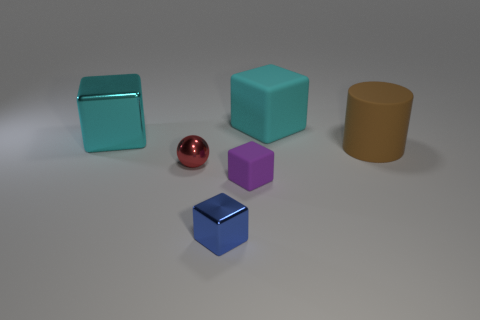What material is the other block that is the same color as the big rubber cube?
Ensure brevity in your answer.  Metal. Do the large metallic block and the big rubber block have the same color?
Offer a terse response. Yes. What number of things are both in front of the big cyan metallic thing and on the right side of the red object?
Offer a very short reply. 3. What number of purple matte things have the same shape as the cyan shiny object?
Your answer should be very brief. 1. What is the color of the matte object on the right side of the large block that is right of the blue thing?
Ensure brevity in your answer.  Brown. Is the shape of the large metallic thing the same as the large rubber thing that is behind the big cyan shiny cube?
Ensure brevity in your answer.  Yes. What is the material of the large block to the right of the sphere that is in front of the cyan cube that is to the right of the large metallic cube?
Your response must be concise. Rubber. Is there another cube that has the same size as the blue shiny block?
Give a very brief answer. Yes. There is a purple block that is made of the same material as the brown cylinder; what is its size?
Provide a short and direct response. Small. What is the shape of the cyan matte object?
Your answer should be compact. Cube. 